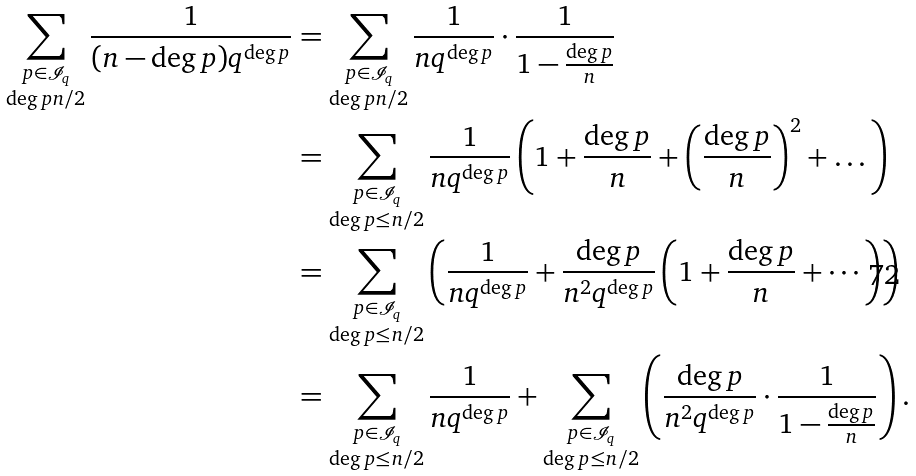<formula> <loc_0><loc_0><loc_500><loc_500>\sum _ { \substack { p \in \mathcal { I } _ { q } \\ \deg p n / 2 } } \frac { 1 } { ( n - \deg p ) q ^ { \deg p } } & = \sum _ { \substack { p \in \mathcal { I } _ { q } \\ \deg p n / 2 } } \frac { 1 } { n q ^ { \deg p } } \cdot \frac { 1 } { 1 - \frac { \deg p } { n } } \\ & = \sum _ { \substack { p \in \mathcal { I } _ { q } \\ \deg p \leq n / 2 } } \frac { 1 } { n q ^ { \deg p } } \left ( 1 + \frac { \deg p } { n } + \left ( \frac { \deg p } { n } \right ) ^ { 2 } + \dots \right ) \\ & = \sum _ { \substack { p \in \mathcal { I } _ { q } \\ \deg p \leq n / 2 } } \left ( \frac { 1 } { n q ^ { \deg p } } + \frac { \deg p } { n ^ { 2 } q ^ { \deg p } } \left ( 1 + \frac { \deg p } { n } + \cdots \right ) \right ) \\ & = \sum _ { \substack { p \in \mathcal { I } _ { q } \\ \deg p \leq n / 2 } } \frac { 1 } { n q ^ { \deg p } } + \sum _ { \substack { p \in \mathcal { I } _ { q } \\ \deg p \leq n / 2 } } \left ( \frac { \deg p } { n ^ { 2 } q ^ { \deg p } } \cdot \frac { 1 } { 1 - \frac { \deg p } { n } } \right ) .</formula> 